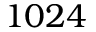Convert formula to latex. <formula><loc_0><loc_0><loc_500><loc_500>1 0 2 4</formula> 